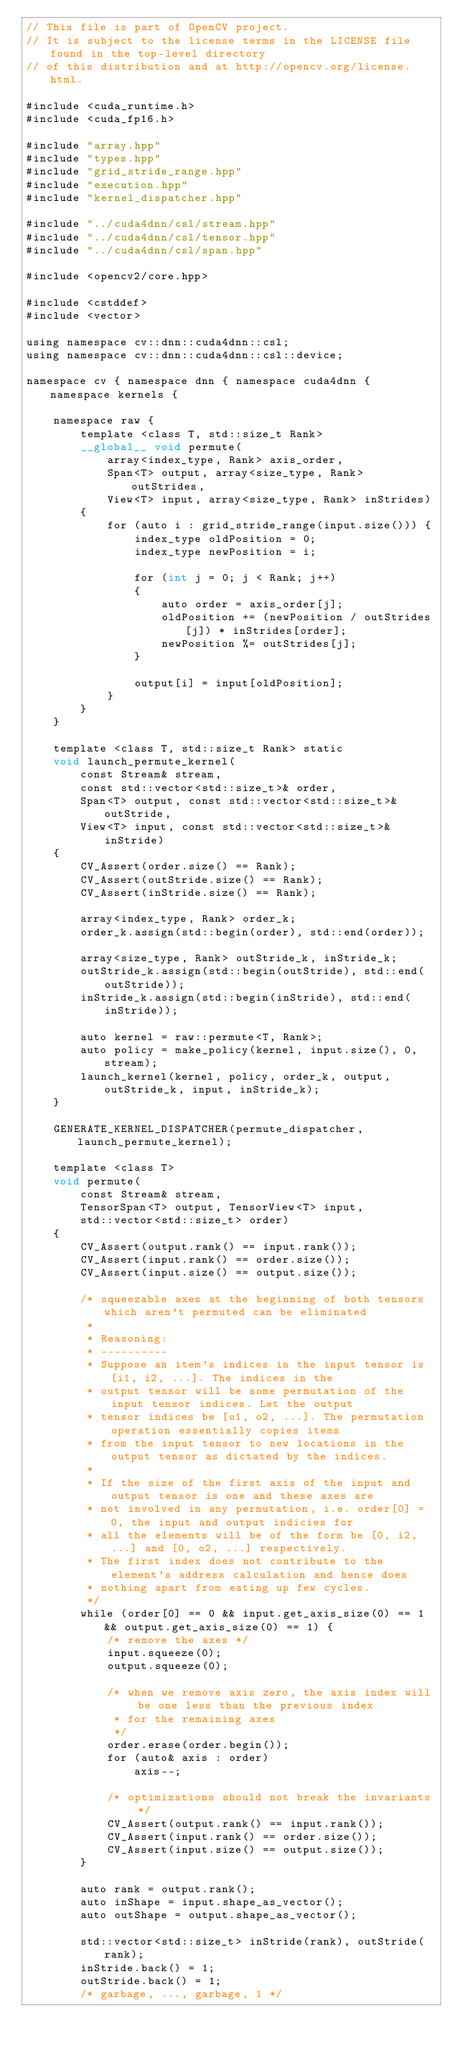<code> <loc_0><loc_0><loc_500><loc_500><_Cuda_>// This file is part of OpenCV project.
// It is subject to the license terms in the LICENSE file found in the top-level directory
// of this distribution and at http://opencv.org/license.html.

#include <cuda_runtime.h>
#include <cuda_fp16.h>

#include "array.hpp"
#include "types.hpp"
#include "grid_stride_range.hpp"
#include "execution.hpp"
#include "kernel_dispatcher.hpp"

#include "../cuda4dnn/csl/stream.hpp"
#include "../cuda4dnn/csl/tensor.hpp"
#include "../cuda4dnn/csl/span.hpp"

#include <opencv2/core.hpp>

#include <cstddef>
#include <vector>

using namespace cv::dnn::cuda4dnn::csl;
using namespace cv::dnn::cuda4dnn::csl::device;

namespace cv { namespace dnn { namespace cuda4dnn { namespace kernels {

    namespace raw {
        template <class T, std::size_t Rank>
        __global__ void permute(
            array<index_type, Rank> axis_order,
            Span<T> output, array<size_type, Rank> outStrides,
            View<T> input, array<size_type, Rank> inStrides)
        {
            for (auto i : grid_stride_range(input.size())) {
                index_type oldPosition = 0;
                index_type newPosition = i;

                for (int j = 0; j < Rank; j++)
                {
                    auto order = axis_order[j];
                    oldPosition += (newPosition / outStrides[j]) * inStrides[order];
                    newPosition %= outStrides[j];
                }

                output[i] = input[oldPosition];
            }
        }
    }

    template <class T, std::size_t Rank> static
    void launch_permute_kernel(
        const Stream& stream,
        const std::vector<std::size_t>& order,
        Span<T> output, const std::vector<std::size_t>& outStride,
        View<T> input, const std::vector<std::size_t>& inStride)
    {
        CV_Assert(order.size() == Rank);
        CV_Assert(outStride.size() == Rank);
        CV_Assert(inStride.size() == Rank);

        array<index_type, Rank> order_k;
        order_k.assign(std::begin(order), std::end(order));

        array<size_type, Rank> outStride_k, inStride_k;
        outStride_k.assign(std::begin(outStride), std::end(outStride));
        inStride_k.assign(std::begin(inStride), std::end(inStride));

        auto kernel = raw::permute<T, Rank>;
        auto policy = make_policy(kernel, input.size(), 0, stream);
        launch_kernel(kernel, policy, order_k, output, outStride_k, input, inStride_k);
    }

    GENERATE_KERNEL_DISPATCHER(permute_dispatcher, launch_permute_kernel);

    template <class T>
    void permute(
        const Stream& stream,
        TensorSpan<T> output, TensorView<T> input,
        std::vector<std::size_t> order)
    {
        CV_Assert(output.rank() == input.rank());
        CV_Assert(input.rank() == order.size());
        CV_Assert(input.size() == output.size());

        /* squeezable axes at the beginning of both tensors which aren't permuted can be eliminated
         *
         * Reasoning:
         * ----------
         * Suppose an item's indices in the input tensor is [i1, i2, ...]. The indices in the
         * output tensor will be some permutation of the input tensor indices. Let the output
         * tensor indices be [o1, o2, ...]. The permutation operation essentially copies items
         * from the input tensor to new locations in the output tensor as dictated by the indices.
         *
         * If the size of the first axis of the input and output tensor is one and these axes are
         * not involved in any permutation, i.e. order[0] = 0, the input and output indicies for
         * all the elements will be of the form be [0, i2, ...] and [0, o2, ...] respectively.
         * The first index does not contribute to the element's address calculation and hence does
         * nothing apart from eating up few cycles.
         */
        while (order[0] == 0 && input.get_axis_size(0) == 1 && output.get_axis_size(0) == 1) {
            /* remove the axes */
            input.squeeze(0);
            output.squeeze(0);

            /* when we remove axis zero, the axis index will be one less than the previous index
             * for the remaining axes
             */
            order.erase(order.begin());
            for (auto& axis : order)
                axis--;

            /* optimizations should not break the invariants */
            CV_Assert(output.rank() == input.rank());
            CV_Assert(input.rank() == order.size());
            CV_Assert(input.size() == output.size());
        }

        auto rank = output.rank();
        auto inShape = input.shape_as_vector();
        auto outShape = output.shape_as_vector();

        std::vector<std::size_t> inStride(rank), outStride(rank);
        inStride.back() = 1;
        outStride.back() = 1;
        /* garbage, ..., garbage, 1 */
</code> 